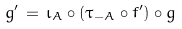Convert formula to latex. <formula><loc_0><loc_0><loc_500><loc_500>g ^ { \prime } \, = \, \iota _ { A } \circ ( \tau _ { - A } \circ f ^ { \prime } ) \circ g</formula> 